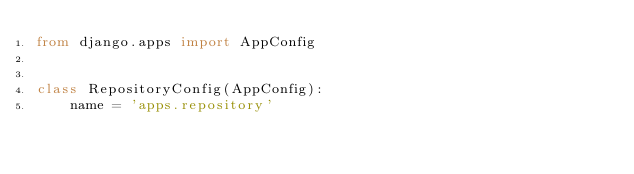Convert code to text. <code><loc_0><loc_0><loc_500><loc_500><_Python_>from django.apps import AppConfig


class RepositoryConfig(AppConfig):
    name = 'apps.repository'
</code> 